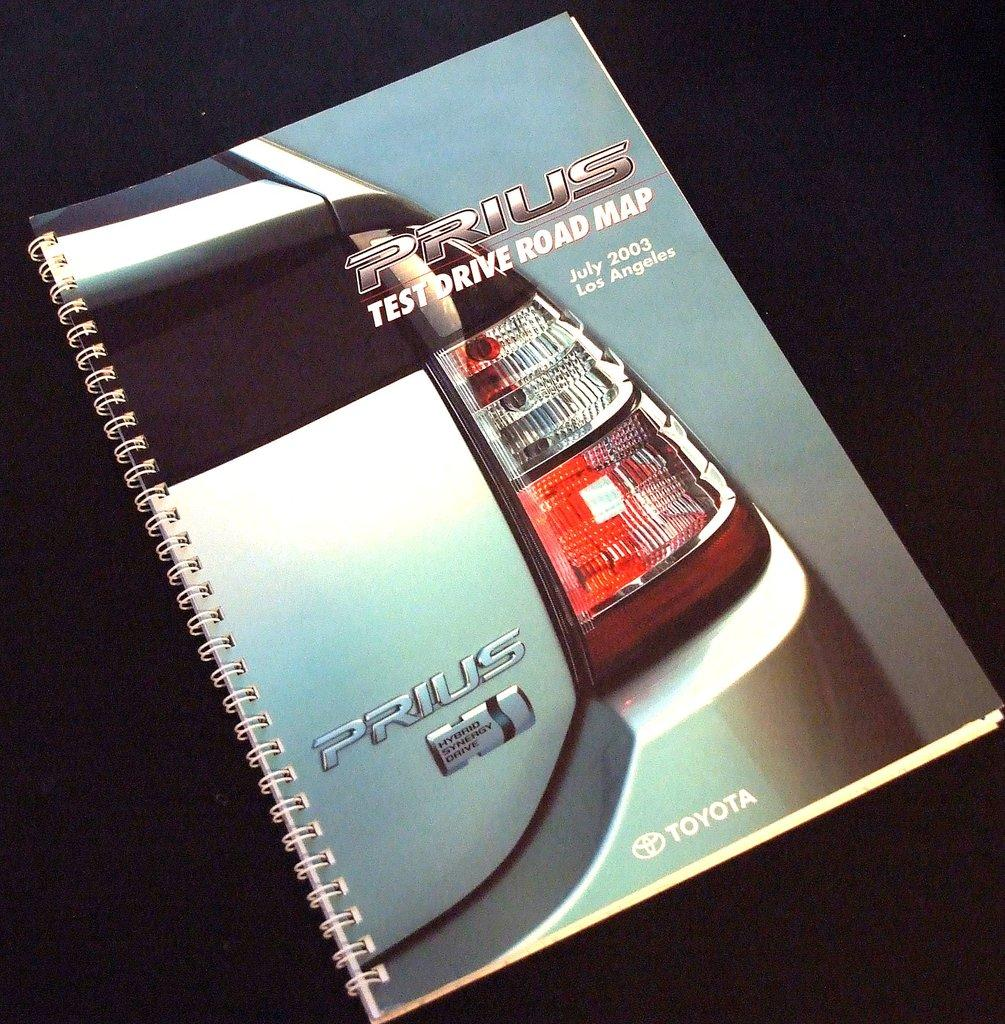What object is the main focus of the image? There is a book in the image. What is shown on the cover of the book? There is a car depicted on the cover of the book. Are there any words or letters on the cover of the book? Yes, there is text printed on the cover of the book. Can you see any grass growing on the cover of the book? No, there is no grass present on the cover of the book. Is there a needle visible on the cover of the book? No, there is no needle present on the cover of the book. 